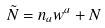Convert formula to latex. <formula><loc_0><loc_0><loc_500><loc_500>\tilde { N } = n _ { a } w ^ { a } + N</formula> 